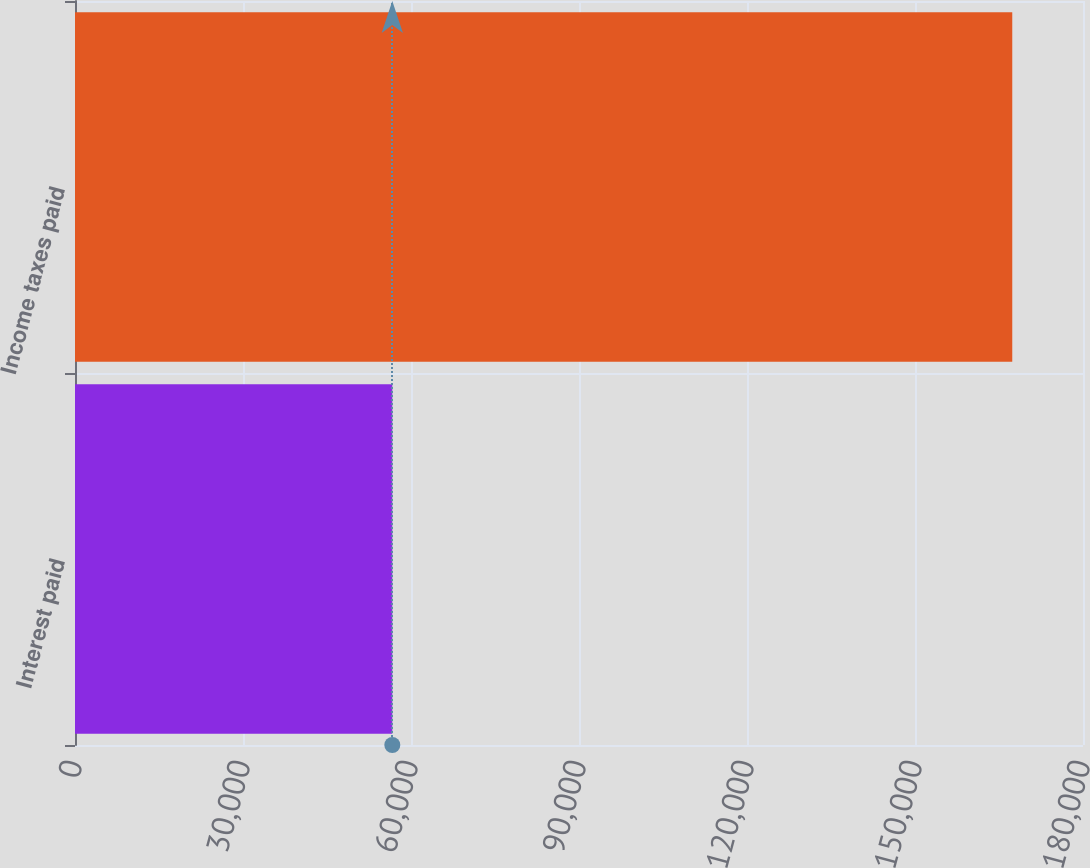Convert chart to OTSL. <chart><loc_0><loc_0><loc_500><loc_500><bar_chart><fcel>Interest paid<fcel>Income taxes paid<nl><fcel>56662<fcel>167367<nl></chart> 